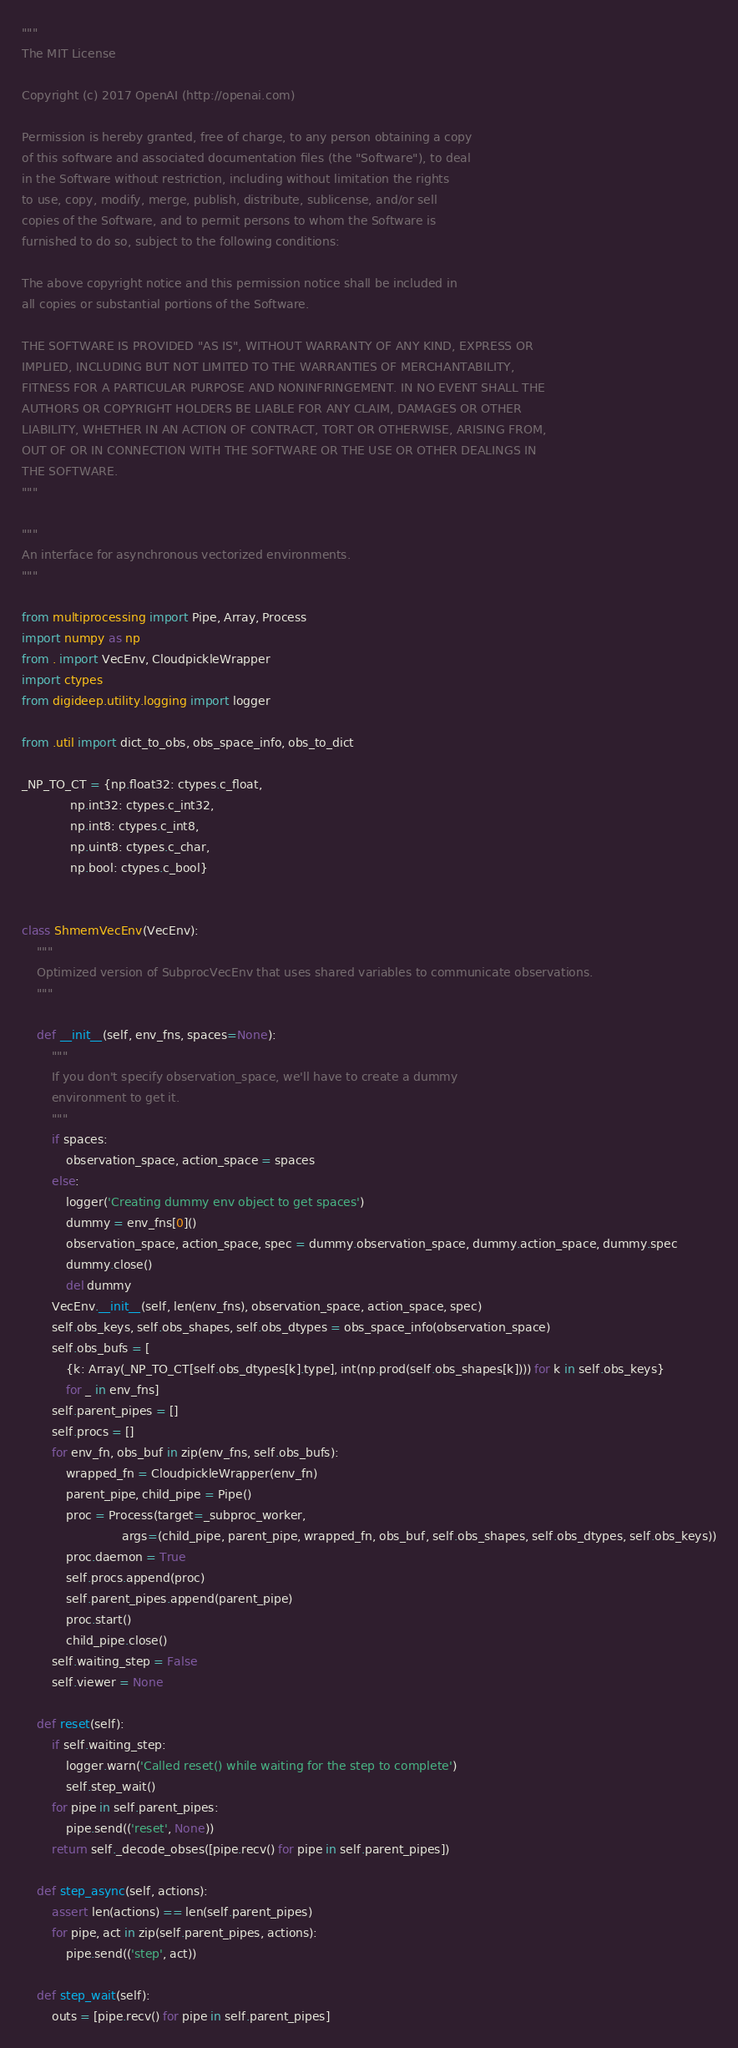Convert code to text. <code><loc_0><loc_0><loc_500><loc_500><_Python_>"""
The MIT License

Copyright (c) 2017 OpenAI (http://openai.com)

Permission is hereby granted, free of charge, to any person obtaining a copy
of this software and associated documentation files (the "Software"), to deal
in the Software without restriction, including without limitation the rights
to use, copy, modify, merge, publish, distribute, sublicense, and/or sell
copies of the Software, and to permit persons to whom the Software is
furnished to do so, subject to the following conditions:

The above copyright notice and this permission notice shall be included in
all copies or substantial portions of the Software.

THE SOFTWARE IS PROVIDED "AS IS", WITHOUT WARRANTY OF ANY KIND, EXPRESS OR
IMPLIED, INCLUDING BUT NOT LIMITED TO THE WARRANTIES OF MERCHANTABILITY,
FITNESS FOR A PARTICULAR PURPOSE AND NONINFRINGEMENT. IN NO EVENT SHALL THE
AUTHORS OR COPYRIGHT HOLDERS BE LIABLE FOR ANY CLAIM, DAMAGES OR OTHER
LIABILITY, WHETHER IN AN ACTION OF CONTRACT, TORT OR OTHERWISE, ARISING FROM,
OUT OF OR IN CONNECTION WITH THE SOFTWARE OR THE USE OR OTHER DEALINGS IN
THE SOFTWARE.
"""

"""
An interface for asynchronous vectorized environments.
"""

from multiprocessing import Pipe, Array, Process
import numpy as np
from . import VecEnv, CloudpickleWrapper
import ctypes
from digideep.utility.logging import logger

from .util import dict_to_obs, obs_space_info, obs_to_dict

_NP_TO_CT = {np.float32: ctypes.c_float,
             np.int32: ctypes.c_int32,
             np.int8: ctypes.c_int8,
             np.uint8: ctypes.c_char,
             np.bool: ctypes.c_bool}


class ShmemVecEnv(VecEnv):
    """
    Optimized version of SubprocVecEnv that uses shared variables to communicate observations.
    """

    def __init__(self, env_fns, spaces=None):
        """
        If you don't specify observation_space, we'll have to create a dummy
        environment to get it.
        """
        if spaces:
            observation_space, action_space = spaces
        else:
            logger('Creating dummy env object to get spaces')
            dummy = env_fns[0]()
            observation_space, action_space, spec = dummy.observation_space, dummy.action_space, dummy.spec
            dummy.close()
            del dummy
        VecEnv.__init__(self, len(env_fns), observation_space, action_space, spec)
        self.obs_keys, self.obs_shapes, self.obs_dtypes = obs_space_info(observation_space)
        self.obs_bufs = [
            {k: Array(_NP_TO_CT[self.obs_dtypes[k].type], int(np.prod(self.obs_shapes[k]))) for k in self.obs_keys}
            for _ in env_fns]
        self.parent_pipes = []
        self.procs = []
        for env_fn, obs_buf in zip(env_fns, self.obs_bufs):
            wrapped_fn = CloudpickleWrapper(env_fn)
            parent_pipe, child_pipe = Pipe()
            proc = Process(target=_subproc_worker,
                           args=(child_pipe, parent_pipe, wrapped_fn, obs_buf, self.obs_shapes, self.obs_dtypes, self.obs_keys))
            proc.daemon = True
            self.procs.append(proc)
            self.parent_pipes.append(parent_pipe)
            proc.start()
            child_pipe.close()
        self.waiting_step = False
        self.viewer = None

    def reset(self):
        if self.waiting_step:
            logger.warn('Called reset() while waiting for the step to complete')
            self.step_wait()
        for pipe in self.parent_pipes:
            pipe.send(('reset', None))
        return self._decode_obses([pipe.recv() for pipe in self.parent_pipes])

    def step_async(self, actions):
        assert len(actions) == len(self.parent_pipes)
        for pipe, act in zip(self.parent_pipes, actions):
            pipe.send(('step', act))

    def step_wait(self):
        outs = [pipe.recv() for pipe in self.parent_pipes]</code> 